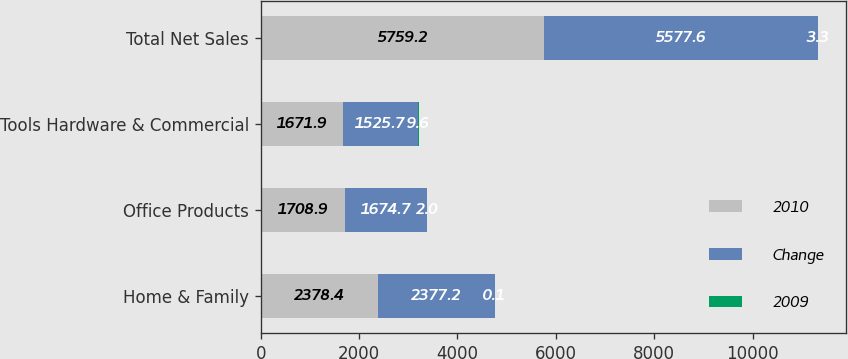<chart> <loc_0><loc_0><loc_500><loc_500><stacked_bar_chart><ecel><fcel>Home & Family<fcel>Office Products<fcel>Tools Hardware & Commercial<fcel>Total Net Sales<nl><fcel>2010<fcel>2378.4<fcel>1708.9<fcel>1671.9<fcel>5759.2<nl><fcel>Change<fcel>2377.2<fcel>1674.7<fcel>1525.7<fcel>5577.6<nl><fcel>2009<fcel>0.1<fcel>2<fcel>9.6<fcel>3.3<nl></chart> 